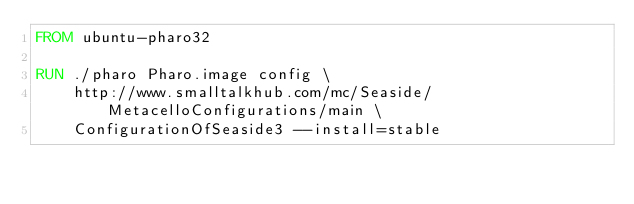<code> <loc_0><loc_0><loc_500><loc_500><_Dockerfile_>FROM ubuntu-pharo32

RUN ./pharo Pharo.image config \
	http://www.smalltalkhub.com/mc/Seaside/MetacelloConfigurations/main \
	ConfigurationOfSeaside3 --install=stable
</code> 